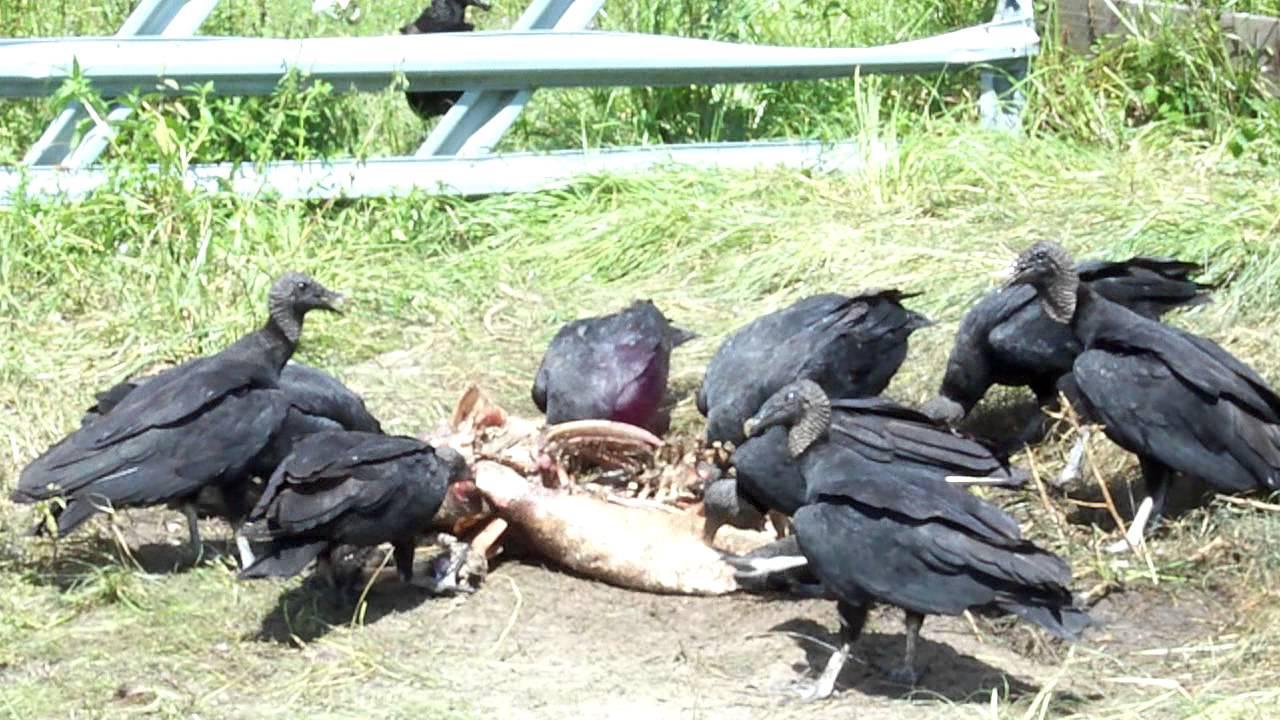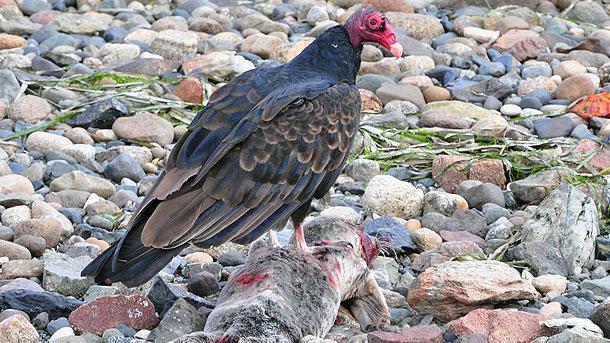The first image is the image on the left, the second image is the image on the right. Evaluate the accuracy of this statement regarding the images: "At least one of the images only has one bird standing on a dead animal.". Is it true? Answer yes or no. Yes. The first image is the image on the left, the second image is the image on the right. Analyze the images presented: Is the assertion "In one of the images, a lone bird is seen at the body of a dead animal." valid? Answer yes or no. Yes. 